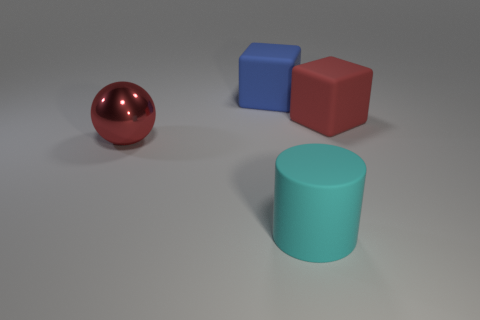Subtract 1 cylinders. How many cylinders are left? 0 Add 1 rubber blocks. How many objects exist? 5 Subtract all red blocks. How many yellow cylinders are left? 0 Subtract all large blue cubes. Subtract all big cyan rubber things. How many objects are left? 2 Add 3 red objects. How many red objects are left? 5 Add 2 small green metal cylinders. How many small green metal cylinders exist? 2 Subtract 1 red spheres. How many objects are left? 3 Subtract all green cubes. Subtract all brown cylinders. How many cubes are left? 2 